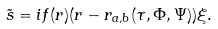Convert formula to latex. <formula><loc_0><loc_0><loc_500><loc_500>\tilde { s } = i f ( r ) ( r - r _ { a , b } ( \tau , \Phi , \Psi ) ) \xi .</formula> 